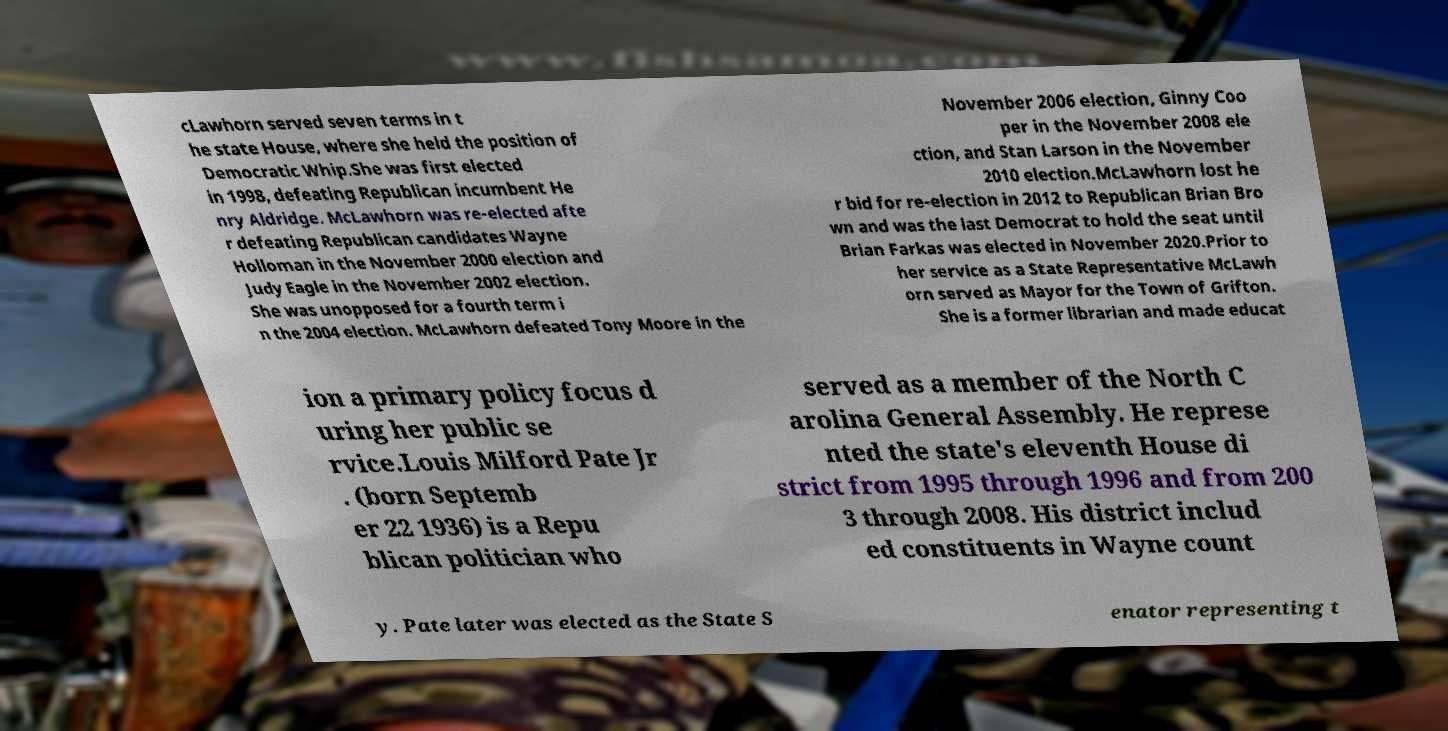Can you accurately transcribe the text from the provided image for me? cLawhorn served seven terms in t he state House, where she held the position of Democratic Whip.She was first elected in 1998, defeating Republican incumbent He nry Aldridge. McLawhorn was re-elected afte r defeating Republican candidates Wayne Holloman in the November 2000 election and Judy Eagle in the November 2002 election. She was unopposed for a fourth term i n the 2004 election. McLawhorn defeated Tony Moore in the November 2006 election, Ginny Coo per in the November 2008 ele ction, and Stan Larson in the November 2010 election.McLawhorn lost he r bid for re-election in 2012 to Republican Brian Bro wn and was the last Democrat to hold the seat until Brian Farkas was elected in November 2020.Prior to her service as a State Representative McLawh orn served as Mayor for the Town of Grifton. She is a former librarian and made educat ion a primary policy focus d uring her public se rvice.Louis Milford Pate Jr . (born Septemb er 22 1936) is a Repu blican politician who served as a member of the North C arolina General Assembly. He represe nted the state's eleventh House di strict from 1995 through 1996 and from 200 3 through 2008. His district includ ed constituents in Wayne count y. Pate later was elected as the State S enator representing t 